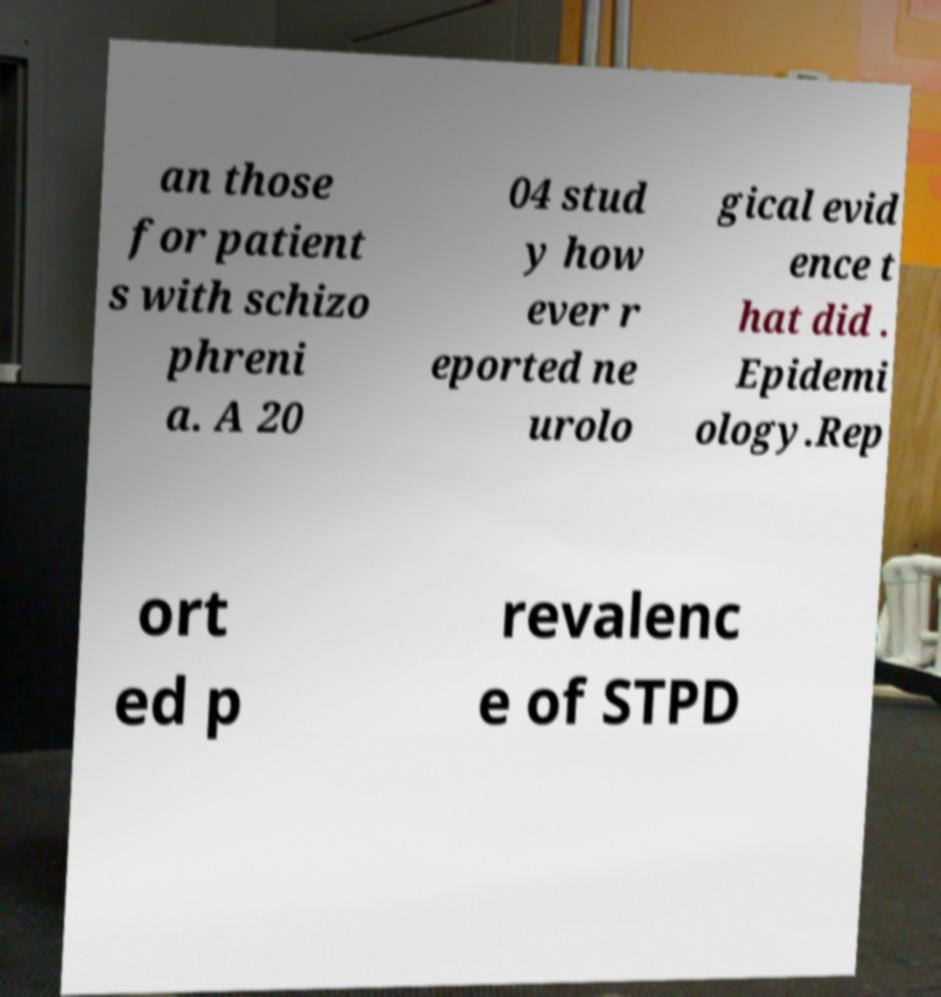Could you assist in decoding the text presented in this image and type it out clearly? an those for patient s with schizo phreni a. A 20 04 stud y how ever r eported ne urolo gical evid ence t hat did . Epidemi ology.Rep ort ed p revalenc e of STPD 